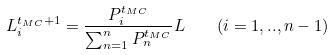Convert formula to latex. <formula><loc_0><loc_0><loc_500><loc_500>L _ { i } ^ { t _ { M C } + 1 } = \frac { P _ { i } ^ { t _ { M C } } } { \sum _ { n = 1 } ^ { n } P _ { n } ^ { t _ { M C } } } L \quad ( i = 1 , . . , n - 1 )</formula> 